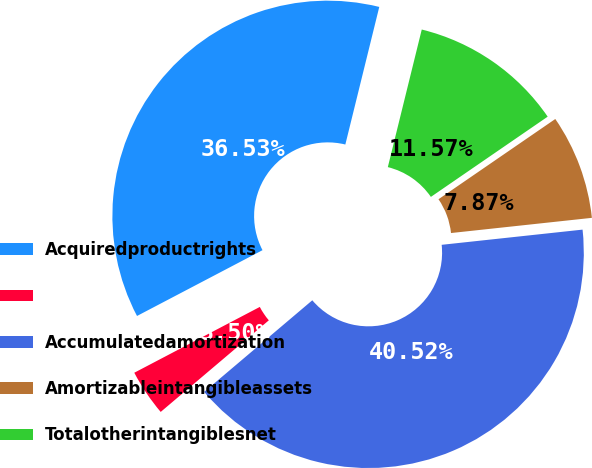Convert chart to OTSL. <chart><loc_0><loc_0><loc_500><loc_500><pie_chart><fcel>Acquiredproductrights<fcel>Unnamed: 1<fcel>Accumulatedamortization<fcel>Amortizableintangibleassets<fcel>Totalotherintangiblesnet<nl><fcel>36.53%<fcel>3.5%<fcel>40.52%<fcel>7.87%<fcel>11.57%<nl></chart> 